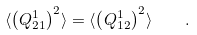Convert formula to latex. <formula><loc_0><loc_0><loc_500><loc_500>\langle \left ( Q _ { 2 1 } ^ { 1 } \right ) ^ { 2 } \rangle = \langle \left ( Q _ { 1 2 } ^ { 1 } \right ) ^ { 2 } \rangle \quad .</formula> 